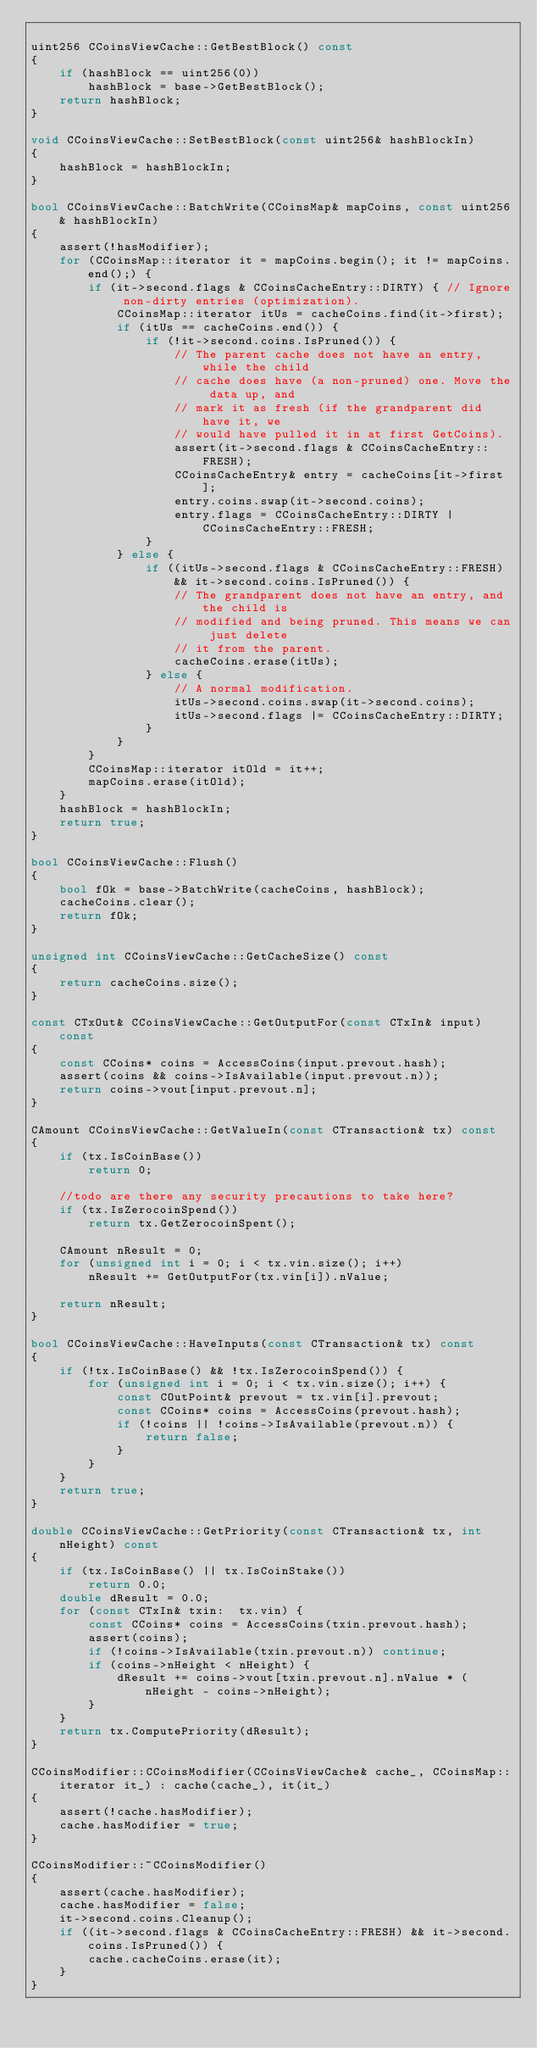<code> <loc_0><loc_0><loc_500><loc_500><_C++_>
uint256 CCoinsViewCache::GetBestBlock() const
{
    if (hashBlock == uint256(0))
        hashBlock = base->GetBestBlock();
    return hashBlock;
}

void CCoinsViewCache::SetBestBlock(const uint256& hashBlockIn)
{
    hashBlock = hashBlockIn;
}

bool CCoinsViewCache::BatchWrite(CCoinsMap& mapCoins, const uint256& hashBlockIn)
{
    assert(!hasModifier);
    for (CCoinsMap::iterator it = mapCoins.begin(); it != mapCoins.end();) {
        if (it->second.flags & CCoinsCacheEntry::DIRTY) { // Ignore non-dirty entries (optimization).
            CCoinsMap::iterator itUs = cacheCoins.find(it->first);
            if (itUs == cacheCoins.end()) {
                if (!it->second.coins.IsPruned()) {
                    // The parent cache does not have an entry, while the child
                    // cache does have (a non-pruned) one. Move the data up, and
                    // mark it as fresh (if the grandparent did have it, we
                    // would have pulled it in at first GetCoins).
                    assert(it->second.flags & CCoinsCacheEntry::FRESH);
                    CCoinsCacheEntry& entry = cacheCoins[it->first];
                    entry.coins.swap(it->second.coins);
                    entry.flags = CCoinsCacheEntry::DIRTY | CCoinsCacheEntry::FRESH;
                }
            } else {
                if ((itUs->second.flags & CCoinsCacheEntry::FRESH) && it->second.coins.IsPruned()) {
                    // The grandparent does not have an entry, and the child is
                    // modified and being pruned. This means we can just delete
                    // it from the parent.
                    cacheCoins.erase(itUs);
                } else {
                    // A normal modification.
                    itUs->second.coins.swap(it->second.coins);
                    itUs->second.flags |= CCoinsCacheEntry::DIRTY;
                }
            }
        }
        CCoinsMap::iterator itOld = it++;
        mapCoins.erase(itOld);
    }
    hashBlock = hashBlockIn;
    return true;
}

bool CCoinsViewCache::Flush()
{
    bool fOk = base->BatchWrite(cacheCoins, hashBlock);
    cacheCoins.clear();
    return fOk;
}

unsigned int CCoinsViewCache::GetCacheSize() const
{
    return cacheCoins.size();
}

const CTxOut& CCoinsViewCache::GetOutputFor(const CTxIn& input) const
{
    const CCoins* coins = AccessCoins(input.prevout.hash);
    assert(coins && coins->IsAvailable(input.prevout.n));
    return coins->vout[input.prevout.n];
}

CAmount CCoinsViewCache::GetValueIn(const CTransaction& tx) const
{
    if (tx.IsCoinBase())
        return 0;

    //todo are there any security precautions to take here?
    if (tx.IsZerocoinSpend())
        return tx.GetZerocoinSpent();

    CAmount nResult = 0;
    for (unsigned int i = 0; i < tx.vin.size(); i++)
        nResult += GetOutputFor(tx.vin[i]).nValue;

    return nResult;
}

bool CCoinsViewCache::HaveInputs(const CTransaction& tx) const
{
    if (!tx.IsCoinBase() && !tx.IsZerocoinSpend()) {
        for (unsigned int i = 0; i < tx.vin.size(); i++) {
            const COutPoint& prevout = tx.vin[i].prevout;
            const CCoins* coins = AccessCoins(prevout.hash);
            if (!coins || !coins->IsAvailable(prevout.n)) {
                return false;
            }
        }
    }
    return true;
}

double CCoinsViewCache::GetPriority(const CTransaction& tx, int nHeight) const
{
    if (tx.IsCoinBase() || tx.IsCoinStake())
        return 0.0;
    double dResult = 0.0;
    for (const CTxIn& txin:  tx.vin) {
        const CCoins* coins = AccessCoins(txin.prevout.hash);
        assert(coins);
        if (!coins->IsAvailable(txin.prevout.n)) continue;
        if (coins->nHeight < nHeight) {
            dResult += coins->vout[txin.prevout.n].nValue * (nHeight - coins->nHeight);
        }
    }
    return tx.ComputePriority(dResult);
}

CCoinsModifier::CCoinsModifier(CCoinsViewCache& cache_, CCoinsMap::iterator it_) : cache(cache_), it(it_)
{
    assert(!cache.hasModifier);
    cache.hasModifier = true;
}

CCoinsModifier::~CCoinsModifier()
{
    assert(cache.hasModifier);
    cache.hasModifier = false;
    it->second.coins.Cleanup();
    if ((it->second.flags & CCoinsCacheEntry::FRESH) && it->second.coins.IsPruned()) {
        cache.cacheCoins.erase(it);
    }
}
</code> 